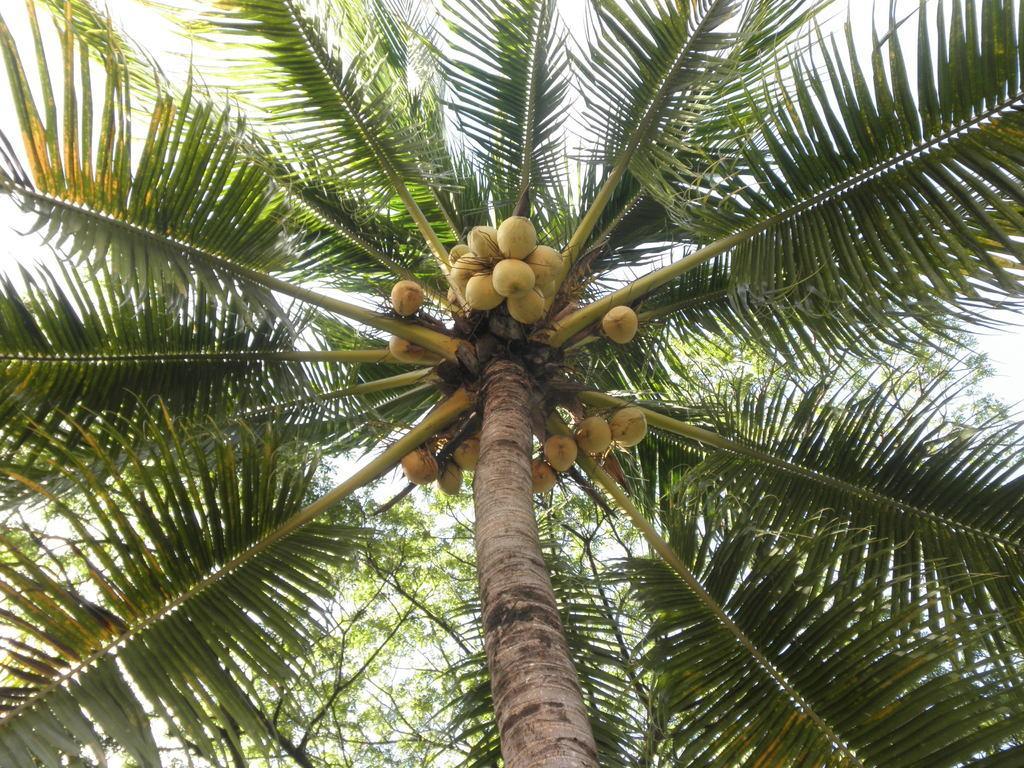Can you describe this image briefly? In the image in the center we can see the sky,clouds,trees and coconuts. 